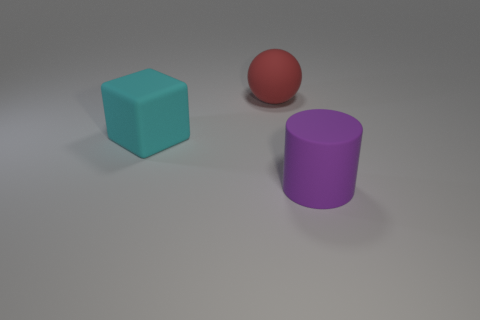Is the number of big purple matte cylinders in front of the large cylinder less than the number of big cyan matte blocks?
Provide a succinct answer. Yes. What is the shape of the cyan thing that is the same material as the big ball?
Keep it short and to the point. Cube. How many rubber objects are large yellow cylinders or big cyan cubes?
Provide a short and direct response. 1. Are there the same number of purple cylinders that are to the left of the cyan cube and green metal spheres?
Your answer should be compact. Yes. There is a big rubber thing to the right of the big sphere; is its color the same as the rubber cube?
Offer a very short reply. No. What is the material of the thing that is both in front of the red sphere and right of the cyan cube?
Ensure brevity in your answer.  Rubber. There is a big thing that is to the right of the large red rubber thing; are there any large red objects in front of it?
Keep it short and to the point. No. Do the cyan cube and the red sphere have the same material?
Give a very brief answer. Yes. What shape is the big rubber object that is both in front of the red ball and on the left side of the big purple object?
Provide a short and direct response. Cube. There is a object that is behind the object on the left side of the rubber ball; how big is it?
Your answer should be compact. Large. 